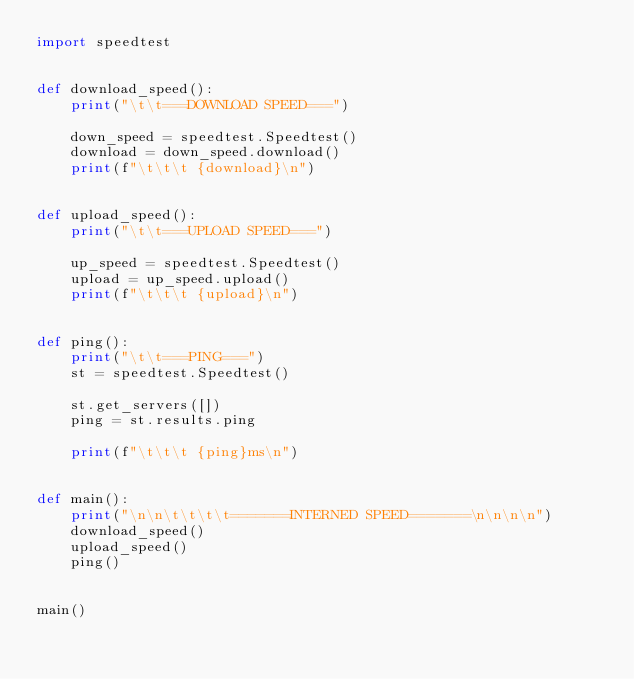Convert code to text. <code><loc_0><loc_0><loc_500><loc_500><_Python_>import speedtest


def download_speed():
    print("\t\t===DOWNLOAD SPEED===")

    down_speed = speedtest.Speedtest()
    download = down_speed.download()
    print(f"\t\t\t {download}\n")


def upload_speed():
    print("\t\t===UPLOAD SPEED===")

    up_speed = speedtest.Speedtest()
    upload = up_speed.upload()
    print(f"\t\t\t {upload}\n")


def ping():
    print("\t\t===PING===")
    st = speedtest.Speedtest()

    st.get_servers([])
    ping = st.results.ping

    print(f"\t\t\t {ping}ms\n")


def main():
    print("\n\n\t\t\t\t=======INTERNED SPEED=======\n\n\n\n")
    download_speed()
    upload_speed()
    ping()


main()
</code> 